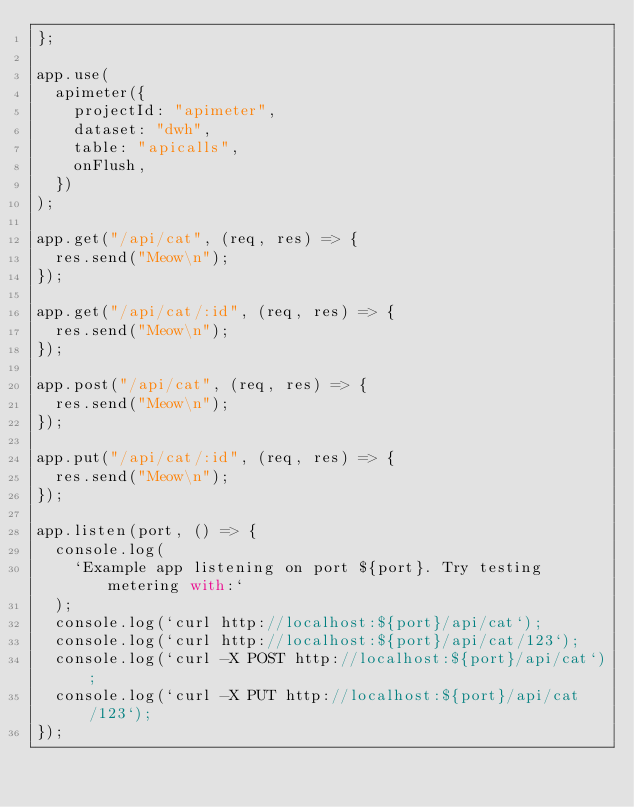<code> <loc_0><loc_0><loc_500><loc_500><_JavaScript_>};

app.use(
  apimeter({
    projectId: "apimeter",
    dataset: "dwh",
    table: "apicalls",
    onFlush,
  })
);

app.get("/api/cat", (req, res) => {
  res.send("Meow\n");
});

app.get("/api/cat/:id", (req, res) => {
  res.send("Meow\n");
});

app.post("/api/cat", (req, res) => {
  res.send("Meow\n");
});

app.put("/api/cat/:id", (req, res) => {
  res.send("Meow\n");
});

app.listen(port, () => {
  console.log(
    `Example app listening on port ${port}. Try testing metering with:`
  );
  console.log(`curl http://localhost:${port}/api/cat`);
  console.log(`curl http://localhost:${port}/api/cat/123`);
  console.log(`curl -X POST http://localhost:${port}/api/cat`);
  console.log(`curl -X PUT http://localhost:${port}/api/cat/123`);
});
</code> 